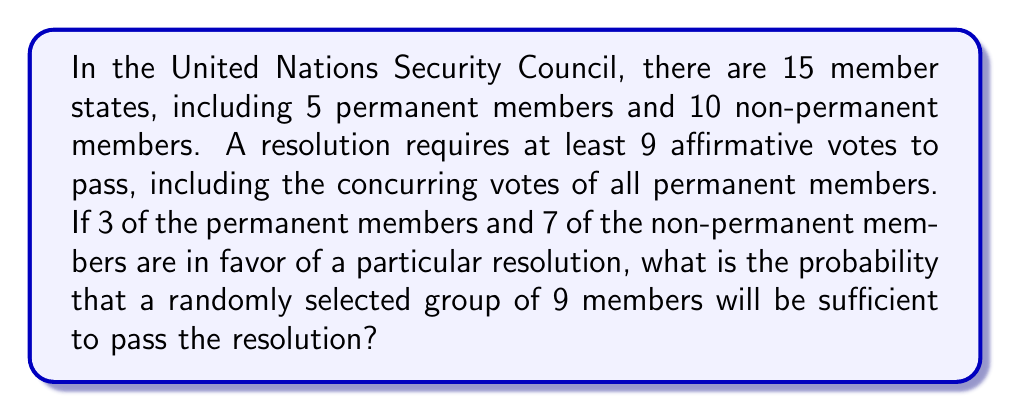Provide a solution to this math problem. To solve this problem, we need to consider the principles of combinations and the specific requirements for passing a resolution in the UN Security Council. Let's break it down step-by-step:

1) First, we need to ensure that all 3 permanent members who are in favor are included in our selection. This is mandatory for the resolution to pass.

2) We then need to select 6 more members from the remaining 12 members (2 permanent members and 10 non-permanent members) to reach the required 9 votes.

3) Out of these 12 remaining members, 7 are in favor (all from non-permanent members) and 5 are not in favor (2 permanent and 3 non-permanent).

4) The question now becomes: what is the probability of selecting at least 6 favorable votes out of 7 when choosing 6 members from 12?

5) We can calculate this using the hypergeometric distribution. The probability is the sum of two scenarios:
   a) Selecting all 6 favorable votes from the 7 available
   b) Selecting 6 favorable votes from 7 available and 0 unfavorable from 5 available

6) We can express this mathematically as:

   $$P = \frac{\binom{7}{6}\binom{5}{0} + \binom{7}{7}\binom{5}{0}}{\binom{12}{6}}$$

7) Let's calculate each combination:
   $\binom{7}{6} = 7$
   $\binom{5}{0} = 1$
   $\binom{7}{7} = 1$
   $\binom{12}{6} = 924$

8) Substituting these values:

   $$P = \frac{7 \cdot 1 + 1 \cdot 1}{924} = \frac{8}{924} = \frac{2}{231} \approx 0.00866$$

Therefore, the probability is $\frac{2}{231}$ or approximately 0.00866 or 0.866%.
Answer: $\frac{2}{231}$ or approximately 0.00866 (0.866%) 